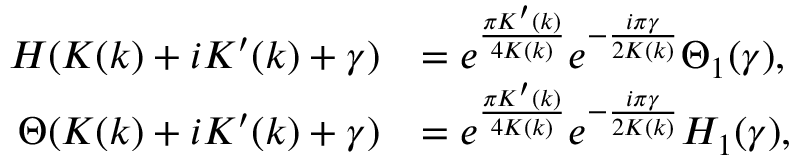Convert formula to latex. <formula><loc_0><loc_0><loc_500><loc_500>\begin{array} { r l } { H ( K ( k ) + i K ^ { \prime } ( k ) + \gamma ) } & { = e ^ { \frac { \pi K ^ { \prime } ( k ) } { 4 K ( k ) } } e ^ { - \frac { i \pi \gamma } { 2 K ( k ) } } \Theta _ { 1 } ( \gamma ) , } \\ { \Theta ( K ( k ) + i K ^ { \prime } ( k ) + \gamma ) } & { = e ^ { \frac { \pi K ^ { \prime } ( k ) } { 4 K ( k ) } } e ^ { - \frac { i \pi \gamma } { 2 K ( k ) } } H _ { 1 } ( \gamma ) , } \end{array}</formula> 